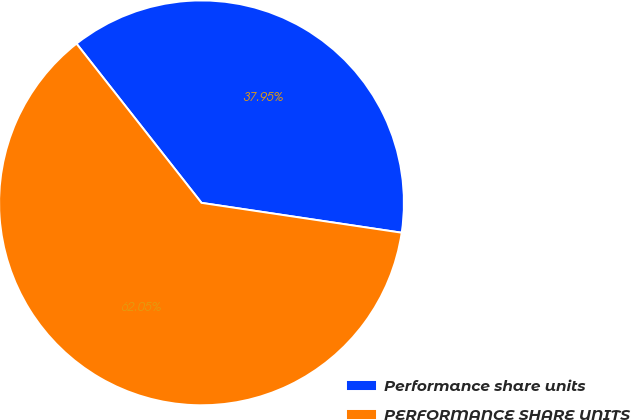<chart> <loc_0><loc_0><loc_500><loc_500><pie_chart><fcel>Performance share units<fcel>PERFORMANCE SHARE UNITS<nl><fcel>37.95%<fcel>62.05%<nl></chart> 